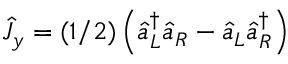Convert formula to latex. <formula><loc_0><loc_0><loc_500><loc_500>\hat { J } _ { y } = ( 1 / 2 ) \left ( \hat { a } _ { L } ^ { \dagger } \hat { a } _ { R } - \hat { a } _ { L } \hat { a } _ { R } ^ { \dagger } \right )</formula> 